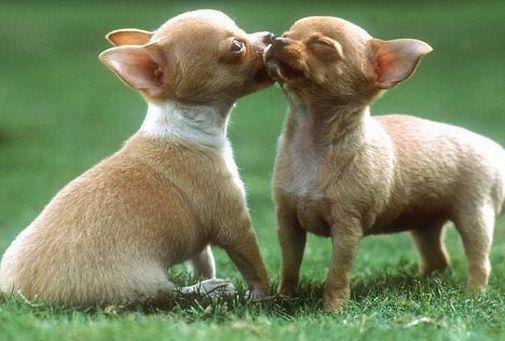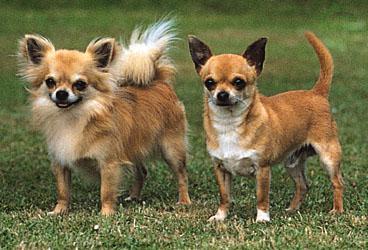The first image is the image on the left, the second image is the image on the right. Given the left and right images, does the statement "The right image contains at least two chihuahua's." hold true? Answer yes or no. Yes. The first image is the image on the left, the second image is the image on the right. Examine the images to the left and right. Is the description "There are three dogs shown" accurate? Answer yes or no. No. 